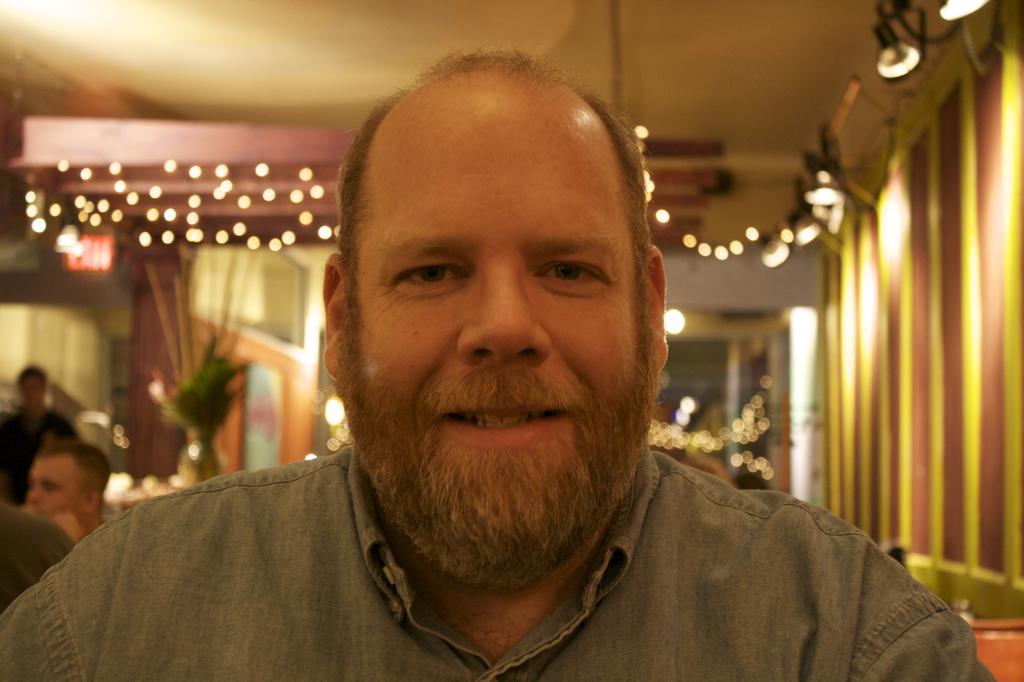Describe this image in one or two sentences. In this image, we can see person wearing clothes. There are some lights in the middle of the image. There is a ceiling at the top of the image. In the background, image is blurred. 